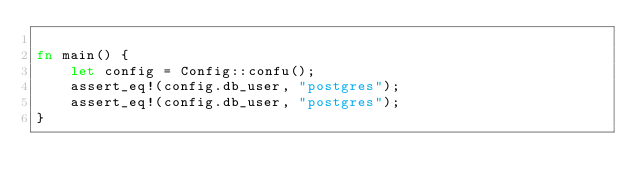Convert code to text. <code><loc_0><loc_0><loc_500><loc_500><_Rust_>
fn main() {
    let config = Config::confu();
    assert_eq!(config.db_user, "postgres");
    assert_eq!(config.db_user, "postgres");
}
</code> 